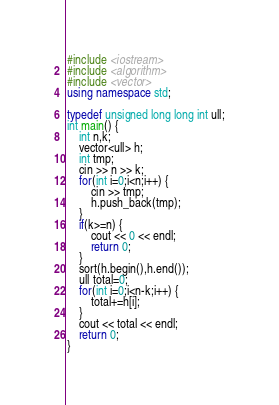<code> <loc_0><loc_0><loc_500><loc_500><_C++_>#include <iostream>
#include <algorithm>
#include <vector>
using namespace std;

typedef unsigned long long int ull;
int main() {
    int n,k;
    vector<ull> h;
    int tmp;
    cin >> n >> k;
    for(int i=0;i<n;i++) {
        cin >> tmp;
        h.push_back(tmp);
    }
    if(k>=n) {
        cout << 0 << endl;
        return 0;
    }
    sort(h.begin(),h.end());
    ull total=0;
    for(int i=0;i<n-k;i++) {
        total+=h[i];
    }
    cout << total << endl;
    return 0; 
}</code> 